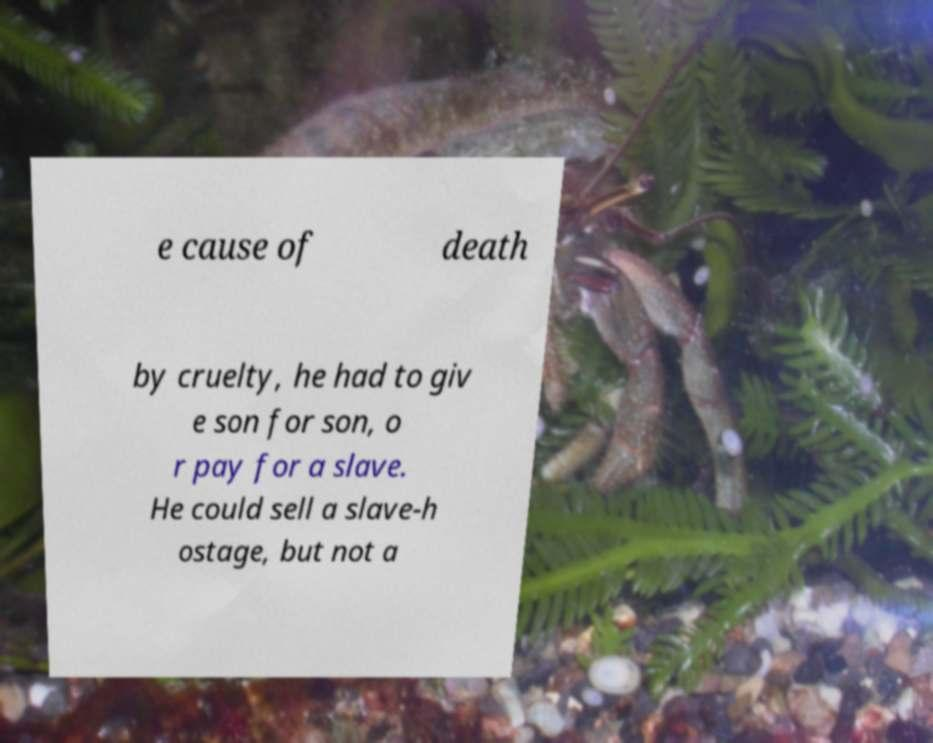Could you extract and type out the text from this image? e cause of death by cruelty, he had to giv e son for son, o r pay for a slave. He could sell a slave-h ostage, but not a 